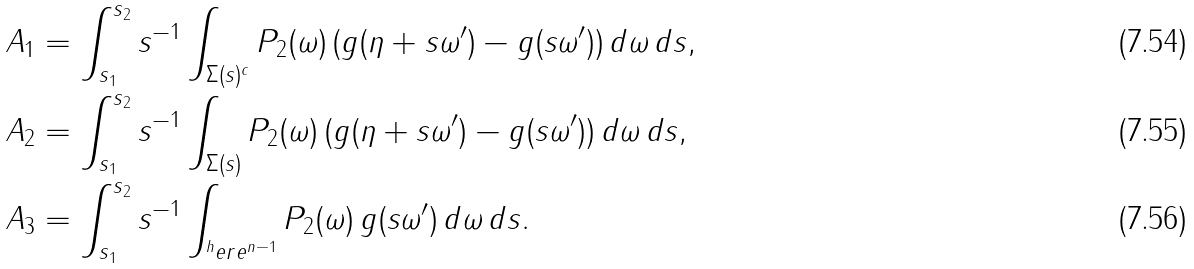<formula> <loc_0><loc_0><loc_500><loc_500>A _ { 1 } & = \int _ { s _ { 1 } } ^ { s _ { 2 } } s ^ { - 1 } \int _ { \Sigma ( s ) ^ { c } } P _ { 2 } ( \omega ) \, ( g ( \eta + s \omega ^ { \prime } ) - g ( s \omega ^ { \prime } ) ) \, d \omega \, d s , \\ A _ { 2 } & = \int _ { s _ { 1 } } ^ { s _ { 2 } } s ^ { - 1 } \int _ { \Sigma ( s ) } P _ { 2 } ( \omega ) \, ( g ( \eta + s \omega ^ { \prime } ) - g ( s \omega ^ { \prime } ) ) \, d \omega \, d s , \\ A _ { 3 } & = \int _ { s _ { 1 } } ^ { s _ { 2 } } s ^ { - 1 } \int _ { ^ { h } e r e ^ { n - 1 } } P _ { 2 } ( \omega ) \, g ( s \omega ^ { \prime } ) \, d \omega \, d s .</formula> 